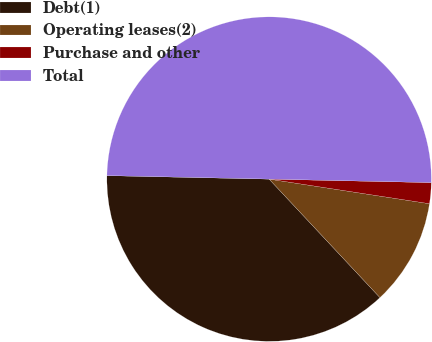Convert chart. <chart><loc_0><loc_0><loc_500><loc_500><pie_chart><fcel>Debt(1)<fcel>Operating leases(2)<fcel>Purchase and other<fcel>Total<nl><fcel>37.31%<fcel>10.61%<fcel>2.08%<fcel>50.0%<nl></chart> 